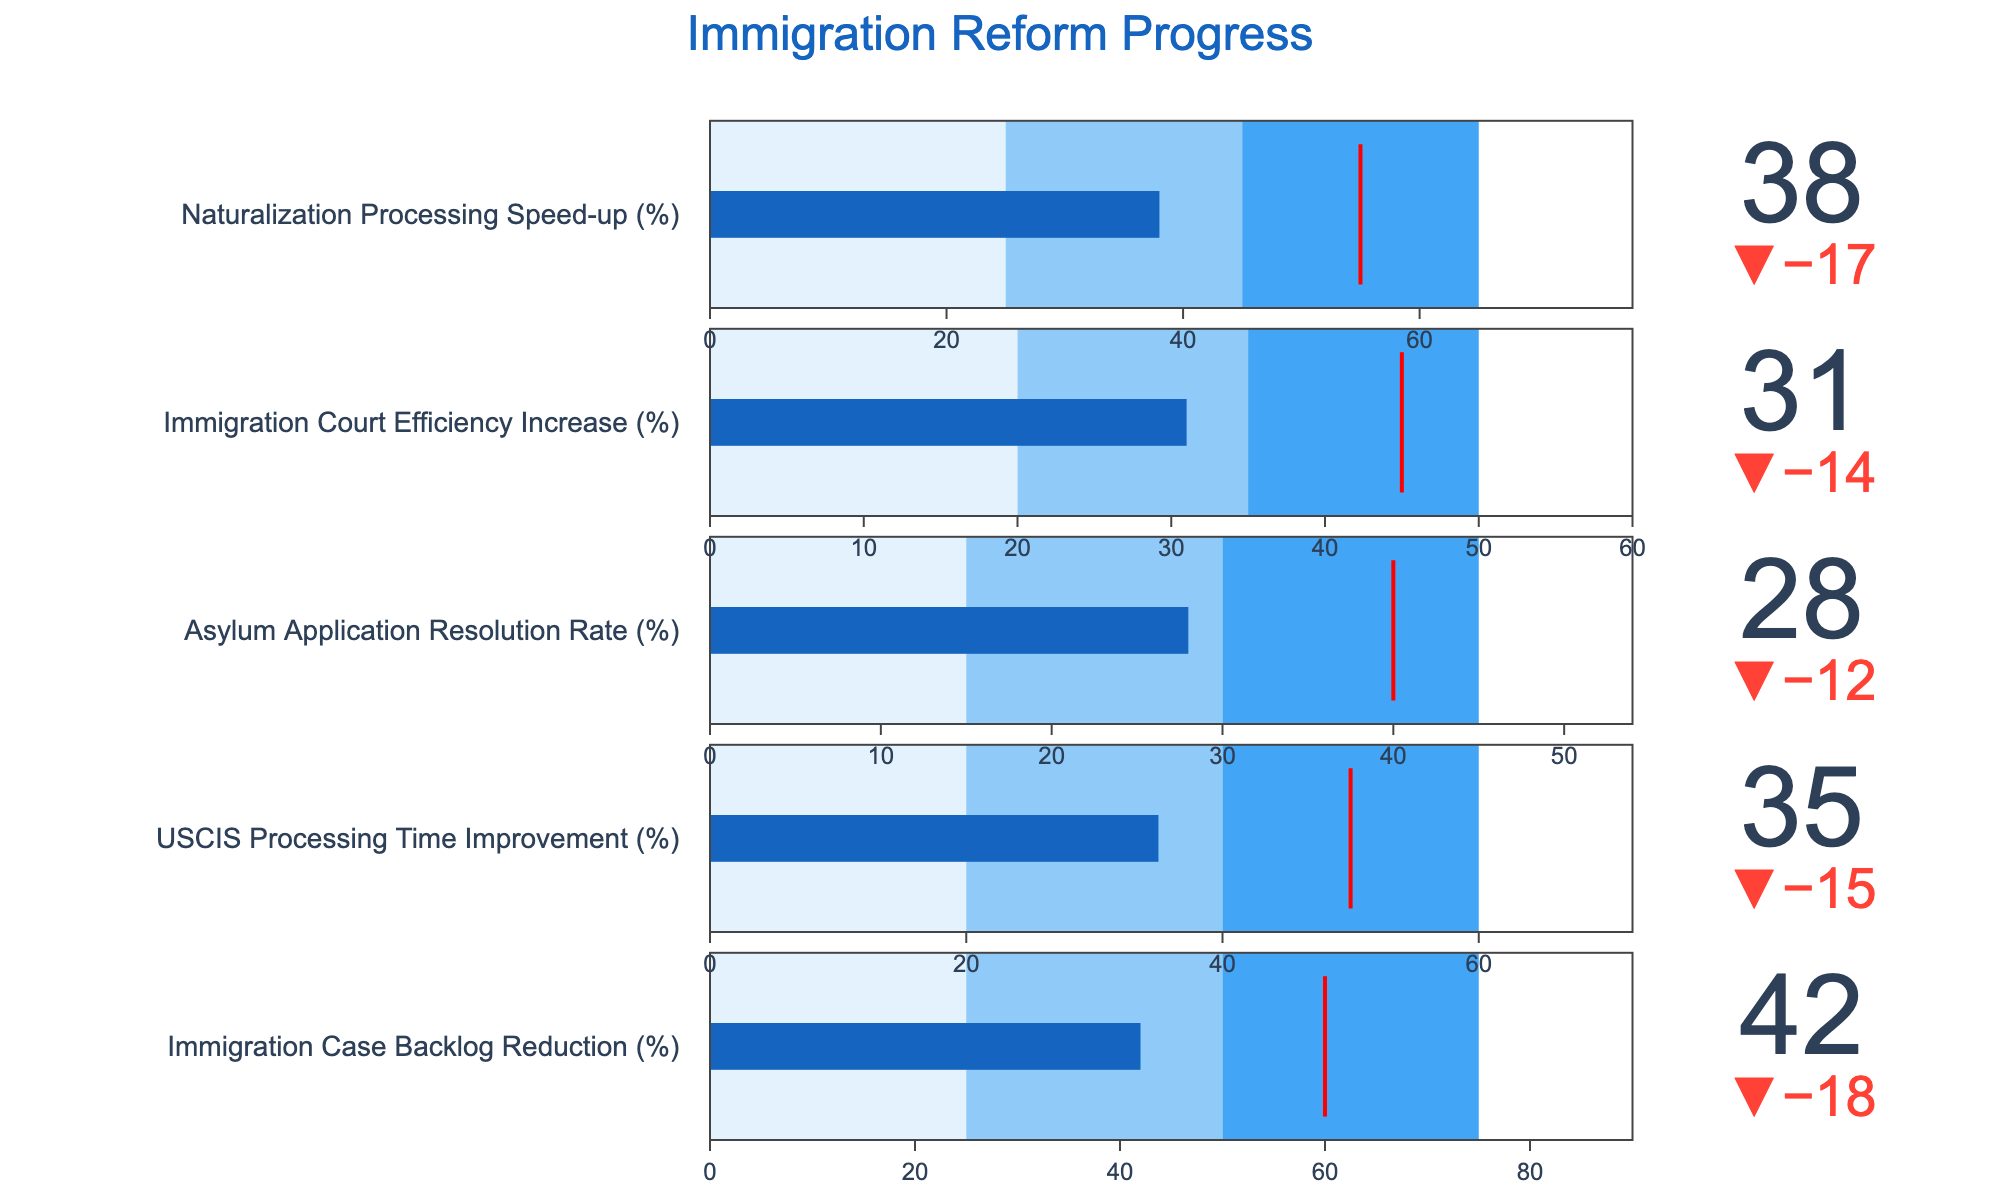What is the maximum percentage target for immigration case backlog reduction? The figure includes a bullet chart titled "Immigration Case Backlog Reduction (%)" which has a target value indicated.
Answer: 60% What is the immigration court efficiency increase rate achieved so far? The figure includes the actual values and targets for different metrics. For "Immigration Court Efficiency Increase (%)", the actual value is indicated.
Answer: 31% Which area has the biggest gap between actual progress and the target? The difference between the actual and target values can be observed for each metric. The largest gap will be the one with the largest delta value. "Asylum Application Resolution Rate (%)" has the largest gap (40% target vs. 28% actual).
Answer: Asylum Application Resolution Rate (%) In which segment does the naturalization processing speed-up rate fall? The bullet chart for "Naturalization Processing Speed-up (%)" shows the actual value in comparison to three ranges (Range1, Range2, Range3). The actual value (38%) falls within Range1 (0-25%), so it is in the next range of 25-45%.
Answer: Second segment (25-45%) How much improvement is needed to reach the USCIS processing time target? The difference between the actual value and the target value for "USCIS Processing Time Improvement (%)" can be calculated as Target - Actual = 50% - 35%.
Answer: 15% Which metric is closest to achieving its target percentage? By comparing the actual values to their corresponding target values, the closest metric is the one with the smallest delta. "Naturalization Processing Speed-up (%)" is closest with its actual value (38%) near its target (55%).
Answer: Naturalization Processing Speed-up (%) How does the actual value of USCIS processing time improvement compare to the range intervals? The range intervals for "USCIS Processing Time Improvement (%)" are from 0-20%, 20-40%, and 40-60%. The actual value (35%) falls within the second interval (20-40%).
Answer: Second interval (20-40%) Which areas have not reached even the first range? Checking the actual values against the first ranges: "Asylum Application Resolution Rate (%)" actual (28%) exceeds 15%; "Immigration Court Efficiency Increase (%)" actual (31%) exceeds 20%; "Naturalization Processing Speed-up (%)" actual (38%) exceeds 25%. Hence, all have exceeded their first range.
Answer: None Is the immigration case backlog reduction rate above or below its second range? The second range for "Immigration Case Backlog Reduction (%)" spans from 25% to 50%. The actual reduction (42%) falls within this range.
Answer: Within the second range 